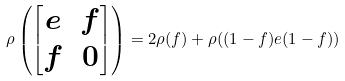Convert formula to latex. <formula><loc_0><loc_0><loc_500><loc_500>\rho \left ( \begin{bmatrix} e & f \\ f & 0 \end{bmatrix} \right ) = 2 \rho ( f ) + \rho ( ( 1 - f ) e ( 1 - f ) )</formula> 